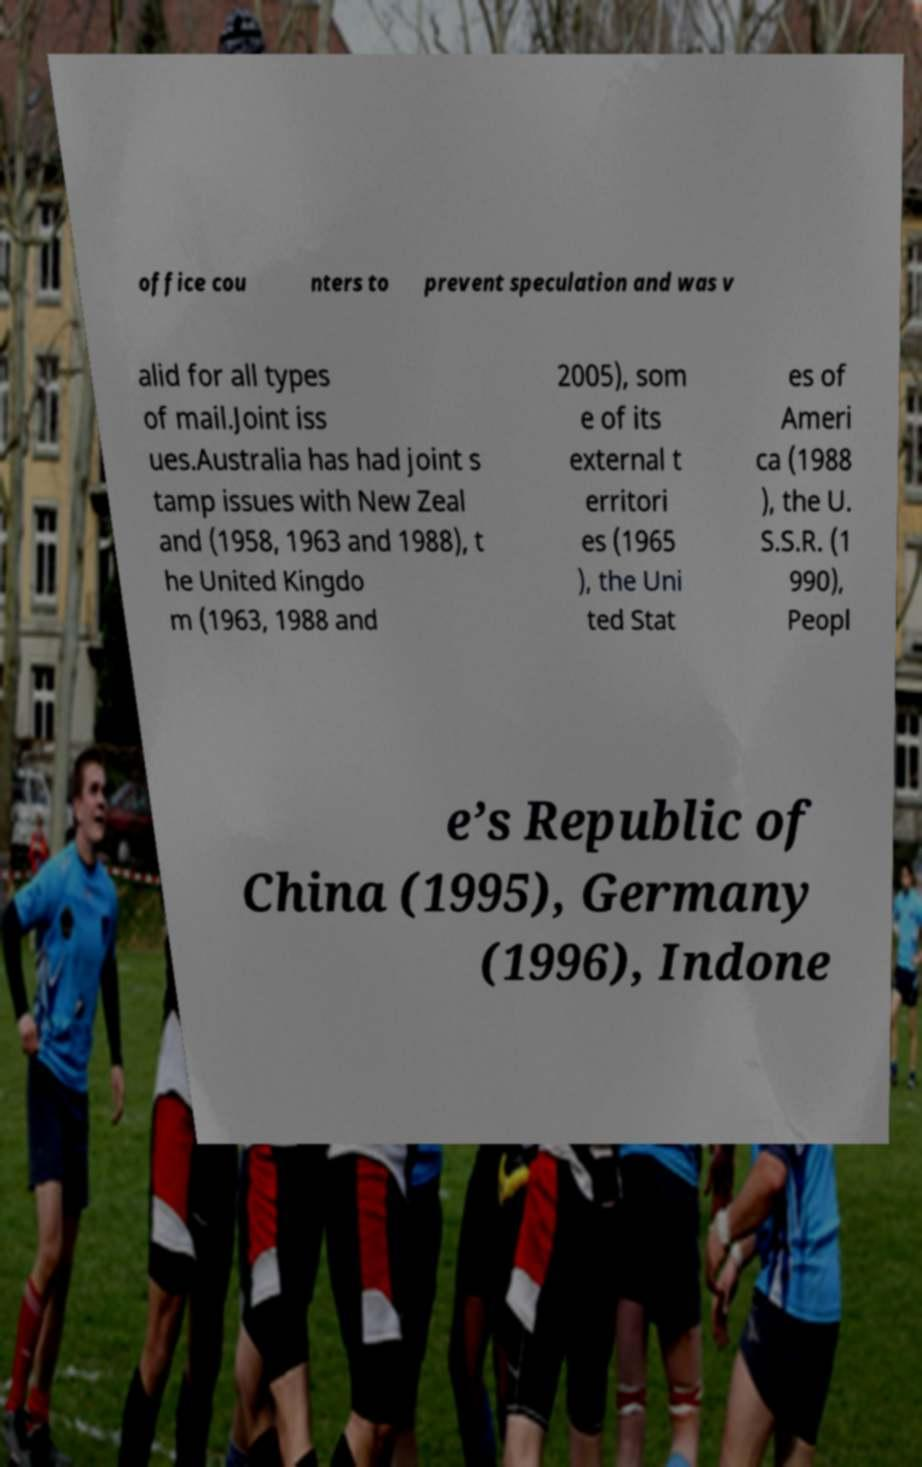Please read and relay the text visible in this image. What does it say? office cou nters to prevent speculation and was v alid for all types of mail.Joint iss ues.Australia has had joint s tamp issues with New Zeal and (1958, 1963 and 1988), t he United Kingdo m (1963, 1988 and 2005), som e of its external t erritori es (1965 ), the Uni ted Stat es of Ameri ca (1988 ), the U. S.S.R. (1 990), Peopl e’s Republic of China (1995), Germany (1996), Indone 